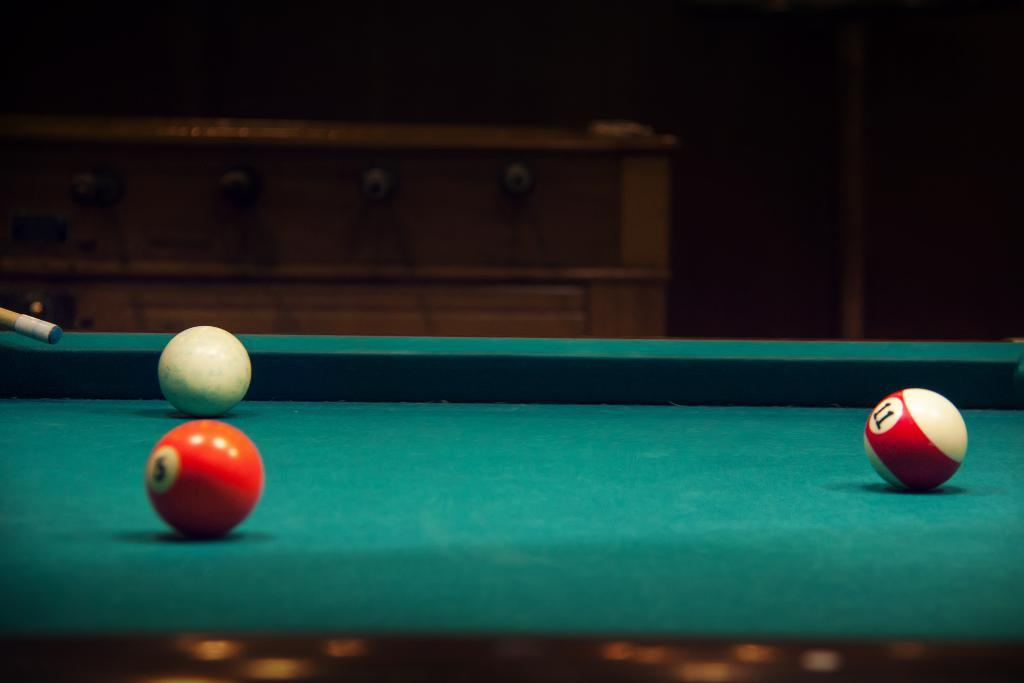What type of game equipment is present in the image? There is a snooker board, three snooker balls, and a snooker stick in the image. How many snooker balls are visible in the image? There are three snooker balls in the image. What is the primary purpose of the snooker stick in the image? The snooker stick is used to hit the snooker balls in the game. What type of fish can be seen swimming in the snooker balls in the image? There are no fish present in the image; it features a snooker board, snooker balls, and a snooker stick. 